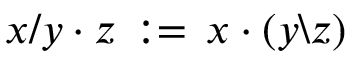<formula> <loc_0><loc_0><loc_500><loc_500>x / y \cdot z \, \colon = \, x \cdot ( y \ z )</formula> 